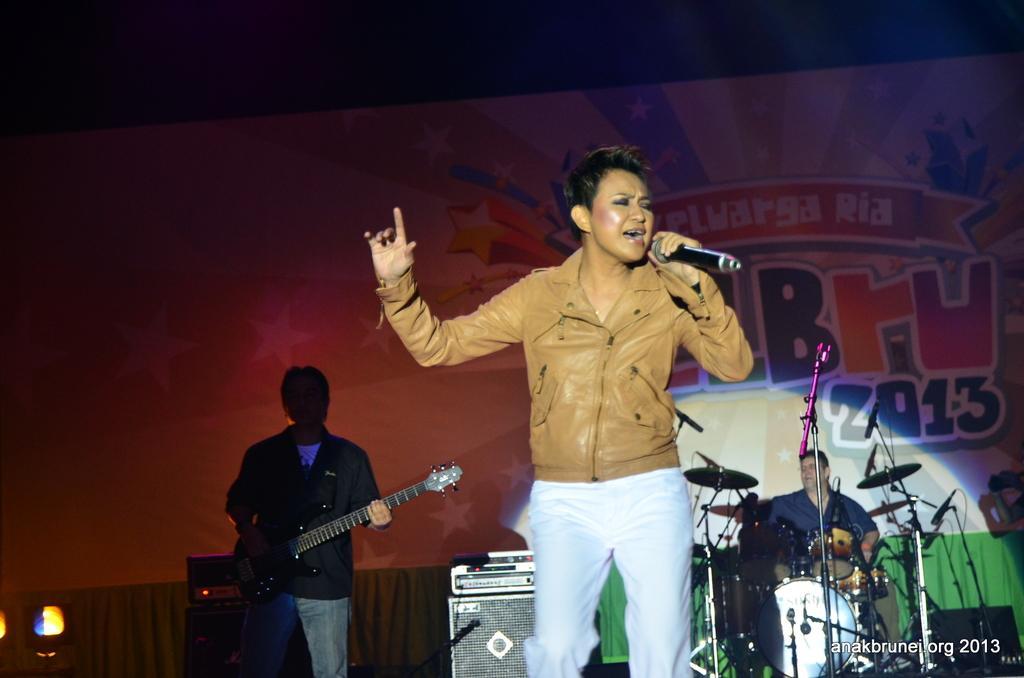Could you give a brief overview of what you see in this image? In this image there are three persons standing. In front the person is holding a mic and two person is playing a musical instruments. 